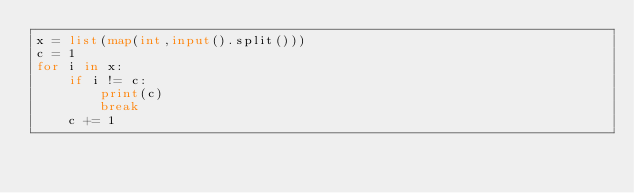Convert code to text. <code><loc_0><loc_0><loc_500><loc_500><_Python_>x = list(map(int,input().split()))
c = 1
for i in x:
    if i != c:
        print(c)
        break
    c += 1</code> 